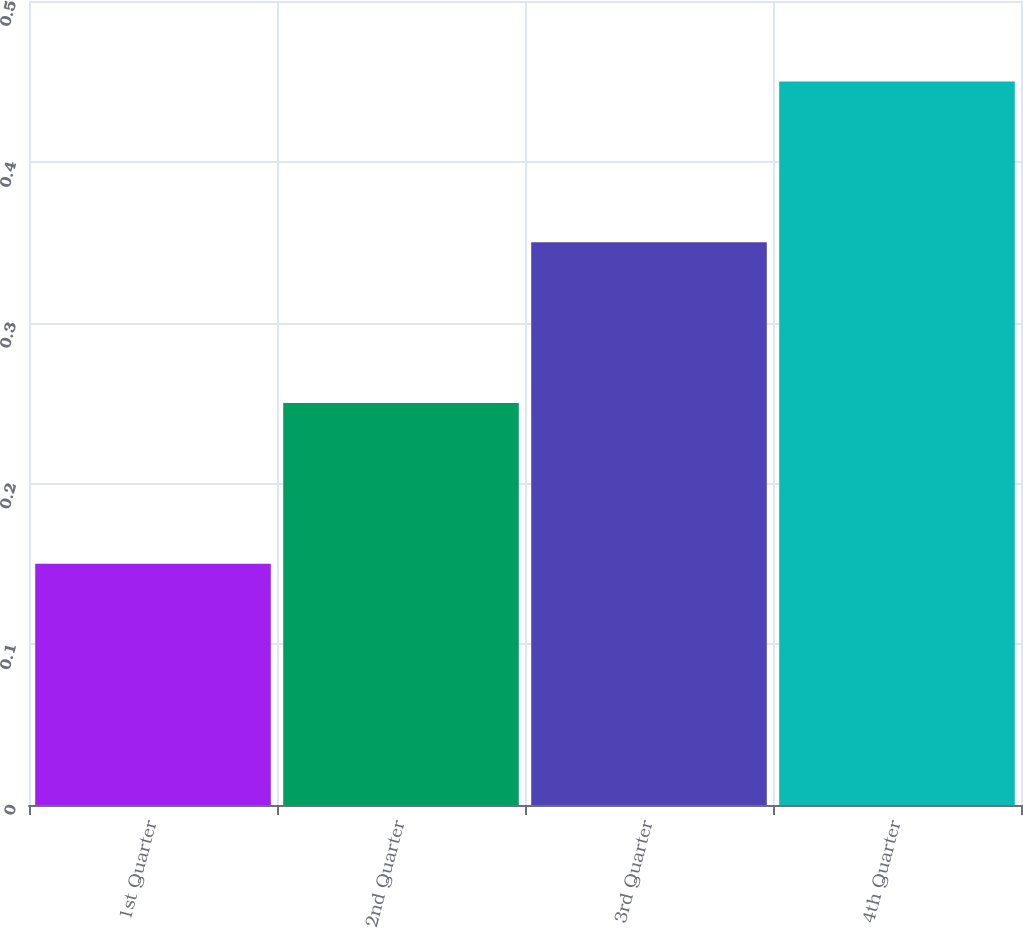<chart> <loc_0><loc_0><loc_500><loc_500><bar_chart><fcel>1st Quarter<fcel>2nd Quarter<fcel>3rd Quarter<fcel>4th Quarter<nl><fcel>0.15<fcel>0.25<fcel>0.35<fcel>0.45<nl></chart> 